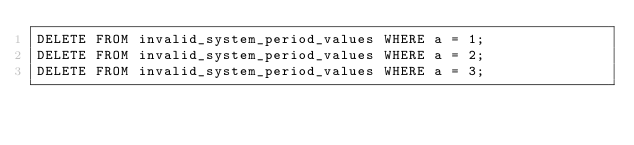Convert code to text. <code><loc_0><loc_0><loc_500><loc_500><_SQL_>DELETE FROM invalid_system_period_values WHERE a = 1;
DELETE FROM invalid_system_period_values WHERE a = 2;
DELETE FROM invalid_system_period_values WHERE a = 3;
</code> 